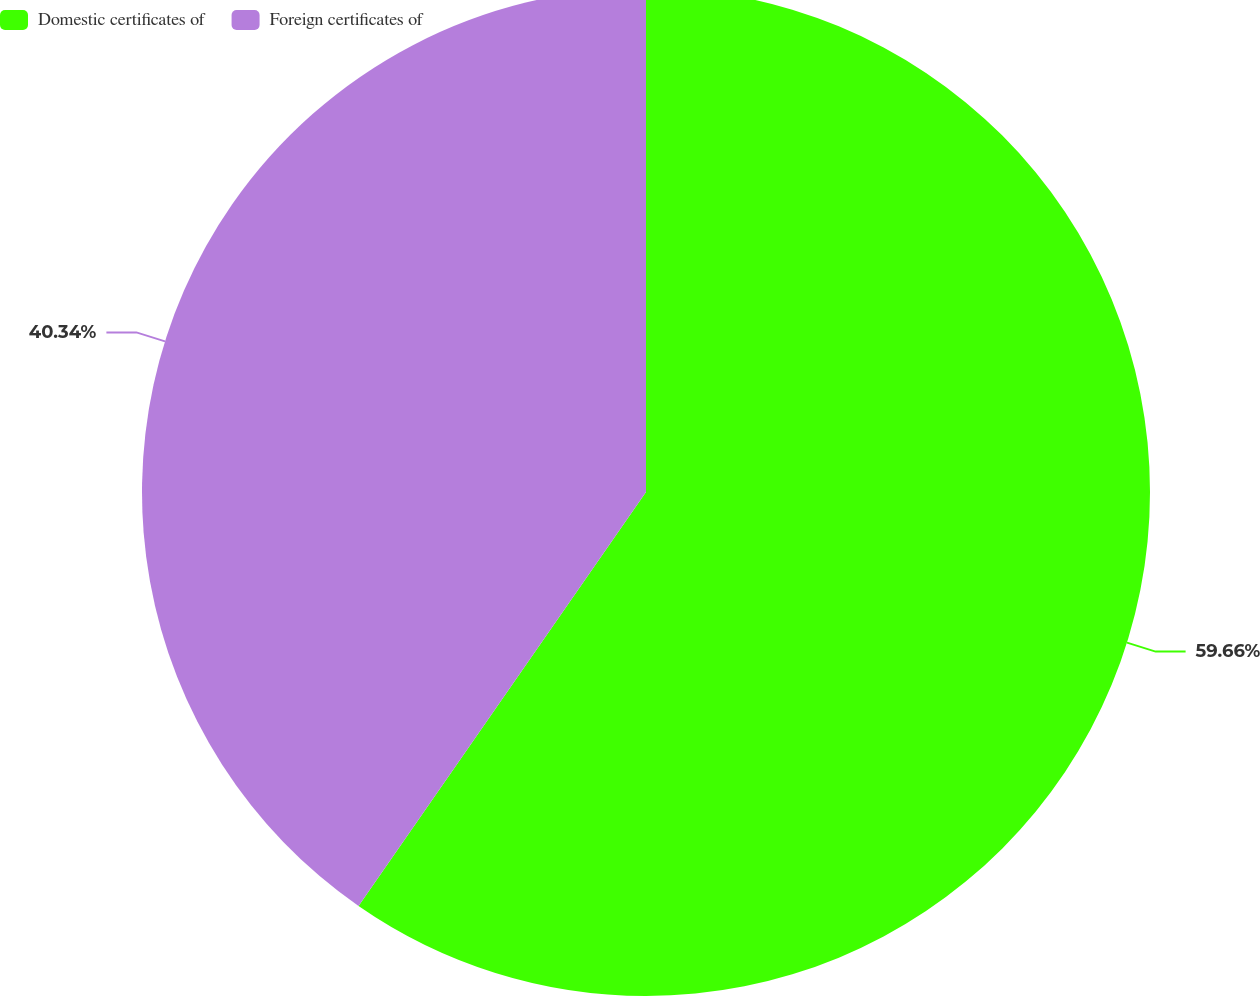Convert chart. <chart><loc_0><loc_0><loc_500><loc_500><pie_chart><fcel>Domestic certificates of<fcel>Foreign certificates of<nl><fcel>59.66%<fcel>40.34%<nl></chart> 